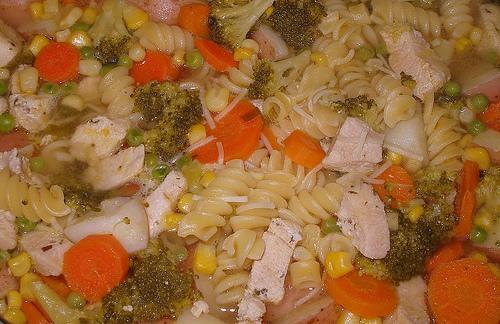How many broccolis are in the photo?
Give a very brief answer. 5. How many carrots are there?
Give a very brief answer. 5. 